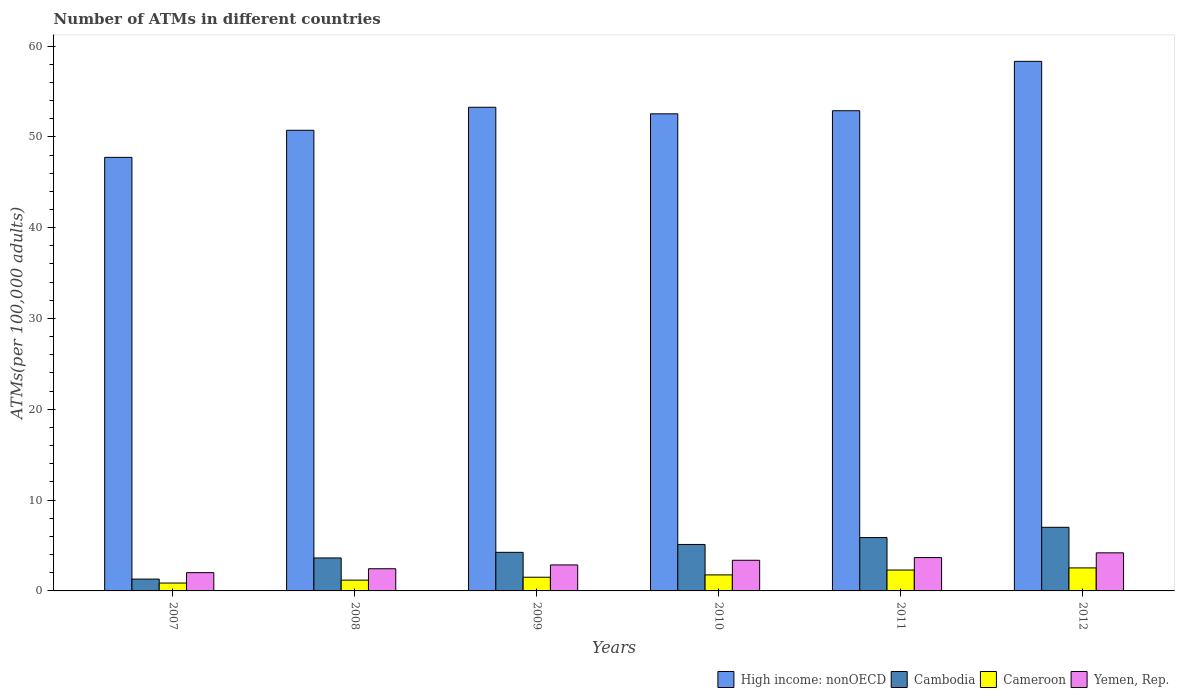Are the number of bars per tick equal to the number of legend labels?
Offer a very short reply. Yes. How many bars are there on the 6th tick from the right?
Offer a terse response. 4. What is the number of ATMs in Cameroon in 2011?
Give a very brief answer. 2.3. Across all years, what is the maximum number of ATMs in Yemen, Rep.?
Your response must be concise. 4.19. Across all years, what is the minimum number of ATMs in Cambodia?
Your response must be concise. 1.3. In which year was the number of ATMs in Yemen, Rep. maximum?
Give a very brief answer. 2012. In which year was the number of ATMs in Cameroon minimum?
Give a very brief answer. 2007. What is the total number of ATMs in Yemen, Rep. in the graph?
Provide a succinct answer. 18.56. What is the difference between the number of ATMs in High income: nonOECD in 2008 and that in 2010?
Provide a short and direct response. -1.81. What is the difference between the number of ATMs in Yemen, Rep. in 2008 and the number of ATMs in Cambodia in 2010?
Your answer should be very brief. -2.67. What is the average number of ATMs in High income: nonOECD per year?
Provide a succinct answer. 52.57. In the year 2011, what is the difference between the number of ATMs in Cambodia and number of ATMs in High income: nonOECD?
Offer a terse response. -47. In how many years, is the number of ATMs in High income: nonOECD greater than 10?
Ensure brevity in your answer.  6. What is the ratio of the number of ATMs in High income: nonOECD in 2010 to that in 2011?
Your answer should be compact. 0.99. Is the number of ATMs in Cameroon in 2009 less than that in 2010?
Give a very brief answer. Yes. Is the difference between the number of ATMs in Cambodia in 2009 and 2010 greater than the difference between the number of ATMs in High income: nonOECD in 2009 and 2010?
Your answer should be compact. No. What is the difference between the highest and the second highest number of ATMs in High income: nonOECD?
Your response must be concise. 5.05. What is the difference between the highest and the lowest number of ATMs in High income: nonOECD?
Make the answer very short. 10.57. What does the 1st bar from the left in 2010 represents?
Make the answer very short. High income: nonOECD. What does the 1st bar from the right in 2011 represents?
Your answer should be very brief. Yemen, Rep. Are all the bars in the graph horizontal?
Make the answer very short. No. How many years are there in the graph?
Make the answer very short. 6. How many legend labels are there?
Ensure brevity in your answer.  4. What is the title of the graph?
Provide a short and direct response. Number of ATMs in different countries. What is the label or title of the Y-axis?
Offer a very short reply. ATMs(per 100,0 adults). What is the ATMs(per 100,000 adults) of High income: nonOECD in 2007?
Offer a very short reply. 47.74. What is the ATMs(per 100,000 adults) of Cambodia in 2007?
Provide a succinct answer. 1.3. What is the ATMs(per 100,000 adults) in Cameroon in 2007?
Ensure brevity in your answer.  0.87. What is the ATMs(per 100,000 adults) of Yemen, Rep. in 2007?
Make the answer very short. 2.01. What is the ATMs(per 100,000 adults) in High income: nonOECD in 2008?
Keep it short and to the point. 50.72. What is the ATMs(per 100,000 adults) of Cambodia in 2008?
Your answer should be very brief. 3.63. What is the ATMs(per 100,000 adults) in Cameroon in 2008?
Your response must be concise. 1.19. What is the ATMs(per 100,000 adults) in Yemen, Rep. in 2008?
Offer a terse response. 2.44. What is the ATMs(per 100,000 adults) of High income: nonOECD in 2009?
Your response must be concise. 53.26. What is the ATMs(per 100,000 adults) of Cambodia in 2009?
Your response must be concise. 4.25. What is the ATMs(per 100,000 adults) of Cameroon in 2009?
Offer a terse response. 1.51. What is the ATMs(per 100,000 adults) of Yemen, Rep. in 2009?
Offer a very short reply. 2.86. What is the ATMs(per 100,000 adults) of High income: nonOECD in 2010?
Provide a succinct answer. 52.53. What is the ATMs(per 100,000 adults) in Cambodia in 2010?
Your answer should be compact. 5.12. What is the ATMs(per 100,000 adults) of Cameroon in 2010?
Ensure brevity in your answer.  1.77. What is the ATMs(per 100,000 adults) of Yemen, Rep. in 2010?
Keep it short and to the point. 3.38. What is the ATMs(per 100,000 adults) of High income: nonOECD in 2011?
Make the answer very short. 52.87. What is the ATMs(per 100,000 adults) in Cambodia in 2011?
Provide a short and direct response. 5.87. What is the ATMs(per 100,000 adults) of Cameroon in 2011?
Give a very brief answer. 2.3. What is the ATMs(per 100,000 adults) of Yemen, Rep. in 2011?
Keep it short and to the point. 3.67. What is the ATMs(per 100,000 adults) of High income: nonOECD in 2012?
Give a very brief answer. 58.31. What is the ATMs(per 100,000 adults) in Cambodia in 2012?
Offer a terse response. 7. What is the ATMs(per 100,000 adults) in Cameroon in 2012?
Keep it short and to the point. 2.53. What is the ATMs(per 100,000 adults) in Yemen, Rep. in 2012?
Give a very brief answer. 4.19. Across all years, what is the maximum ATMs(per 100,000 adults) in High income: nonOECD?
Offer a terse response. 58.31. Across all years, what is the maximum ATMs(per 100,000 adults) of Cambodia?
Give a very brief answer. 7. Across all years, what is the maximum ATMs(per 100,000 adults) of Cameroon?
Your answer should be very brief. 2.53. Across all years, what is the maximum ATMs(per 100,000 adults) of Yemen, Rep.?
Ensure brevity in your answer.  4.19. Across all years, what is the minimum ATMs(per 100,000 adults) in High income: nonOECD?
Your response must be concise. 47.74. Across all years, what is the minimum ATMs(per 100,000 adults) of Cambodia?
Offer a very short reply. 1.3. Across all years, what is the minimum ATMs(per 100,000 adults) in Cameroon?
Offer a very short reply. 0.87. Across all years, what is the minimum ATMs(per 100,000 adults) of Yemen, Rep.?
Your answer should be compact. 2.01. What is the total ATMs(per 100,000 adults) of High income: nonOECD in the graph?
Provide a succinct answer. 315.44. What is the total ATMs(per 100,000 adults) of Cambodia in the graph?
Your answer should be compact. 27.18. What is the total ATMs(per 100,000 adults) in Cameroon in the graph?
Provide a short and direct response. 10.16. What is the total ATMs(per 100,000 adults) of Yemen, Rep. in the graph?
Give a very brief answer. 18.56. What is the difference between the ATMs(per 100,000 adults) in High income: nonOECD in 2007 and that in 2008?
Offer a terse response. -2.98. What is the difference between the ATMs(per 100,000 adults) in Cambodia in 2007 and that in 2008?
Provide a succinct answer. -2.33. What is the difference between the ATMs(per 100,000 adults) of Cameroon in 2007 and that in 2008?
Provide a short and direct response. -0.32. What is the difference between the ATMs(per 100,000 adults) of Yemen, Rep. in 2007 and that in 2008?
Provide a succinct answer. -0.43. What is the difference between the ATMs(per 100,000 adults) of High income: nonOECD in 2007 and that in 2009?
Your response must be concise. -5.52. What is the difference between the ATMs(per 100,000 adults) in Cambodia in 2007 and that in 2009?
Make the answer very short. -2.94. What is the difference between the ATMs(per 100,000 adults) of Cameroon in 2007 and that in 2009?
Your answer should be compact. -0.64. What is the difference between the ATMs(per 100,000 adults) of Yemen, Rep. in 2007 and that in 2009?
Your answer should be compact. -0.85. What is the difference between the ATMs(per 100,000 adults) of High income: nonOECD in 2007 and that in 2010?
Offer a terse response. -4.8. What is the difference between the ATMs(per 100,000 adults) of Cambodia in 2007 and that in 2010?
Keep it short and to the point. -3.81. What is the difference between the ATMs(per 100,000 adults) of Cameroon in 2007 and that in 2010?
Make the answer very short. -0.9. What is the difference between the ATMs(per 100,000 adults) of Yemen, Rep. in 2007 and that in 2010?
Your response must be concise. -1.36. What is the difference between the ATMs(per 100,000 adults) in High income: nonOECD in 2007 and that in 2011?
Your response must be concise. -5.14. What is the difference between the ATMs(per 100,000 adults) of Cambodia in 2007 and that in 2011?
Provide a succinct answer. -4.57. What is the difference between the ATMs(per 100,000 adults) of Cameroon in 2007 and that in 2011?
Offer a terse response. -1.43. What is the difference between the ATMs(per 100,000 adults) in Yemen, Rep. in 2007 and that in 2011?
Keep it short and to the point. -1.66. What is the difference between the ATMs(per 100,000 adults) in High income: nonOECD in 2007 and that in 2012?
Your answer should be very brief. -10.57. What is the difference between the ATMs(per 100,000 adults) in Cambodia in 2007 and that in 2012?
Offer a very short reply. -5.7. What is the difference between the ATMs(per 100,000 adults) of Cameroon in 2007 and that in 2012?
Your answer should be very brief. -1.67. What is the difference between the ATMs(per 100,000 adults) of Yemen, Rep. in 2007 and that in 2012?
Keep it short and to the point. -2.18. What is the difference between the ATMs(per 100,000 adults) in High income: nonOECD in 2008 and that in 2009?
Give a very brief answer. -2.53. What is the difference between the ATMs(per 100,000 adults) of Cambodia in 2008 and that in 2009?
Offer a terse response. -0.62. What is the difference between the ATMs(per 100,000 adults) of Cameroon in 2008 and that in 2009?
Your answer should be very brief. -0.32. What is the difference between the ATMs(per 100,000 adults) of Yemen, Rep. in 2008 and that in 2009?
Give a very brief answer. -0.42. What is the difference between the ATMs(per 100,000 adults) of High income: nonOECD in 2008 and that in 2010?
Ensure brevity in your answer.  -1.81. What is the difference between the ATMs(per 100,000 adults) in Cambodia in 2008 and that in 2010?
Make the answer very short. -1.49. What is the difference between the ATMs(per 100,000 adults) in Cameroon in 2008 and that in 2010?
Ensure brevity in your answer.  -0.58. What is the difference between the ATMs(per 100,000 adults) in Yemen, Rep. in 2008 and that in 2010?
Provide a succinct answer. -0.93. What is the difference between the ATMs(per 100,000 adults) of High income: nonOECD in 2008 and that in 2011?
Your answer should be compact. -2.15. What is the difference between the ATMs(per 100,000 adults) in Cambodia in 2008 and that in 2011?
Your answer should be compact. -2.24. What is the difference between the ATMs(per 100,000 adults) in Cameroon in 2008 and that in 2011?
Ensure brevity in your answer.  -1.11. What is the difference between the ATMs(per 100,000 adults) in Yemen, Rep. in 2008 and that in 2011?
Give a very brief answer. -1.23. What is the difference between the ATMs(per 100,000 adults) of High income: nonOECD in 2008 and that in 2012?
Ensure brevity in your answer.  -7.59. What is the difference between the ATMs(per 100,000 adults) of Cambodia in 2008 and that in 2012?
Give a very brief answer. -3.37. What is the difference between the ATMs(per 100,000 adults) in Cameroon in 2008 and that in 2012?
Provide a succinct answer. -1.35. What is the difference between the ATMs(per 100,000 adults) in Yemen, Rep. in 2008 and that in 2012?
Provide a short and direct response. -1.75. What is the difference between the ATMs(per 100,000 adults) of High income: nonOECD in 2009 and that in 2010?
Offer a terse response. 0.72. What is the difference between the ATMs(per 100,000 adults) in Cambodia in 2009 and that in 2010?
Offer a terse response. -0.87. What is the difference between the ATMs(per 100,000 adults) in Cameroon in 2009 and that in 2010?
Provide a succinct answer. -0.26. What is the difference between the ATMs(per 100,000 adults) in Yemen, Rep. in 2009 and that in 2010?
Make the answer very short. -0.51. What is the difference between the ATMs(per 100,000 adults) in High income: nonOECD in 2009 and that in 2011?
Keep it short and to the point. 0.38. What is the difference between the ATMs(per 100,000 adults) of Cambodia in 2009 and that in 2011?
Your answer should be very brief. -1.62. What is the difference between the ATMs(per 100,000 adults) of Cameroon in 2009 and that in 2011?
Give a very brief answer. -0.79. What is the difference between the ATMs(per 100,000 adults) in Yemen, Rep. in 2009 and that in 2011?
Give a very brief answer. -0.81. What is the difference between the ATMs(per 100,000 adults) in High income: nonOECD in 2009 and that in 2012?
Your answer should be compact. -5.05. What is the difference between the ATMs(per 100,000 adults) in Cambodia in 2009 and that in 2012?
Your answer should be compact. -2.76. What is the difference between the ATMs(per 100,000 adults) in Cameroon in 2009 and that in 2012?
Keep it short and to the point. -1.03. What is the difference between the ATMs(per 100,000 adults) in Yemen, Rep. in 2009 and that in 2012?
Provide a succinct answer. -1.33. What is the difference between the ATMs(per 100,000 adults) of High income: nonOECD in 2010 and that in 2011?
Give a very brief answer. -0.34. What is the difference between the ATMs(per 100,000 adults) of Cambodia in 2010 and that in 2011?
Keep it short and to the point. -0.76. What is the difference between the ATMs(per 100,000 adults) in Cameroon in 2010 and that in 2011?
Offer a very short reply. -0.53. What is the difference between the ATMs(per 100,000 adults) in Yemen, Rep. in 2010 and that in 2011?
Keep it short and to the point. -0.29. What is the difference between the ATMs(per 100,000 adults) of High income: nonOECD in 2010 and that in 2012?
Ensure brevity in your answer.  -5.78. What is the difference between the ATMs(per 100,000 adults) of Cambodia in 2010 and that in 2012?
Provide a short and direct response. -1.89. What is the difference between the ATMs(per 100,000 adults) in Cameroon in 2010 and that in 2012?
Provide a short and direct response. -0.77. What is the difference between the ATMs(per 100,000 adults) of Yemen, Rep. in 2010 and that in 2012?
Your answer should be very brief. -0.82. What is the difference between the ATMs(per 100,000 adults) of High income: nonOECD in 2011 and that in 2012?
Offer a very short reply. -5.44. What is the difference between the ATMs(per 100,000 adults) in Cambodia in 2011 and that in 2012?
Keep it short and to the point. -1.13. What is the difference between the ATMs(per 100,000 adults) of Cameroon in 2011 and that in 2012?
Your answer should be very brief. -0.24. What is the difference between the ATMs(per 100,000 adults) in Yemen, Rep. in 2011 and that in 2012?
Provide a short and direct response. -0.52. What is the difference between the ATMs(per 100,000 adults) of High income: nonOECD in 2007 and the ATMs(per 100,000 adults) of Cambodia in 2008?
Offer a terse response. 44.11. What is the difference between the ATMs(per 100,000 adults) of High income: nonOECD in 2007 and the ATMs(per 100,000 adults) of Cameroon in 2008?
Provide a short and direct response. 46.55. What is the difference between the ATMs(per 100,000 adults) in High income: nonOECD in 2007 and the ATMs(per 100,000 adults) in Yemen, Rep. in 2008?
Offer a terse response. 45.3. What is the difference between the ATMs(per 100,000 adults) in Cambodia in 2007 and the ATMs(per 100,000 adults) in Cameroon in 2008?
Give a very brief answer. 0.11. What is the difference between the ATMs(per 100,000 adults) in Cambodia in 2007 and the ATMs(per 100,000 adults) in Yemen, Rep. in 2008?
Give a very brief answer. -1.14. What is the difference between the ATMs(per 100,000 adults) of Cameroon in 2007 and the ATMs(per 100,000 adults) of Yemen, Rep. in 2008?
Offer a very short reply. -1.57. What is the difference between the ATMs(per 100,000 adults) in High income: nonOECD in 2007 and the ATMs(per 100,000 adults) in Cambodia in 2009?
Give a very brief answer. 43.49. What is the difference between the ATMs(per 100,000 adults) in High income: nonOECD in 2007 and the ATMs(per 100,000 adults) in Cameroon in 2009?
Your answer should be very brief. 46.23. What is the difference between the ATMs(per 100,000 adults) in High income: nonOECD in 2007 and the ATMs(per 100,000 adults) in Yemen, Rep. in 2009?
Keep it short and to the point. 44.88. What is the difference between the ATMs(per 100,000 adults) in Cambodia in 2007 and the ATMs(per 100,000 adults) in Cameroon in 2009?
Provide a succinct answer. -0.2. What is the difference between the ATMs(per 100,000 adults) of Cambodia in 2007 and the ATMs(per 100,000 adults) of Yemen, Rep. in 2009?
Provide a short and direct response. -1.56. What is the difference between the ATMs(per 100,000 adults) of Cameroon in 2007 and the ATMs(per 100,000 adults) of Yemen, Rep. in 2009?
Offer a terse response. -1.99. What is the difference between the ATMs(per 100,000 adults) of High income: nonOECD in 2007 and the ATMs(per 100,000 adults) of Cambodia in 2010?
Provide a short and direct response. 42.62. What is the difference between the ATMs(per 100,000 adults) in High income: nonOECD in 2007 and the ATMs(per 100,000 adults) in Cameroon in 2010?
Your answer should be compact. 45.97. What is the difference between the ATMs(per 100,000 adults) of High income: nonOECD in 2007 and the ATMs(per 100,000 adults) of Yemen, Rep. in 2010?
Offer a terse response. 44.36. What is the difference between the ATMs(per 100,000 adults) in Cambodia in 2007 and the ATMs(per 100,000 adults) in Cameroon in 2010?
Provide a succinct answer. -0.46. What is the difference between the ATMs(per 100,000 adults) of Cambodia in 2007 and the ATMs(per 100,000 adults) of Yemen, Rep. in 2010?
Your answer should be very brief. -2.07. What is the difference between the ATMs(per 100,000 adults) in Cameroon in 2007 and the ATMs(per 100,000 adults) in Yemen, Rep. in 2010?
Offer a terse response. -2.51. What is the difference between the ATMs(per 100,000 adults) of High income: nonOECD in 2007 and the ATMs(per 100,000 adults) of Cambodia in 2011?
Offer a terse response. 41.87. What is the difference between the ATMs(per 100,000 adults) in High income: nonOECD in 2007 and the ATMs(per 100,000 adults) in Cameroon in 2011?
Give a very brief answer. 45.44. What is the difference between the ATMs(per 100,000 adults) of High income: nonOECD in 2007 and the ATMs(per 100,000 adults) of Yemen, Rep. in 2011?
Your answer should be compact. 44.07. What is the difference between the ATMs(per 100,000 adults) in Cambodia in 2007 and the ATMs(per 100,000 adults) in Cameroon in 2011?
Provide a short and direct response. -1. What is the difference between the ATMs(per 100,000 adults) in Cambodia in 2007 and the ATMs(per 100,000 adults) in Yemen, Rep. in 2011?
Give a very brief answer. -2.37. What is the difference between the ATMs(per 100,000 adults) in Cameroon in 2007 and the ATMs(per 100,000 adults) in Yemen, Rep. in 2011?
Your response must be concise. -2.8. What is the difference between the ATMs(per 100,000 adults) in High income: nonOECD in 2007 and the ATMs(per 100,000 adults) in Cambodia in 2012?
Your response must be concise. 40.73. What is the difference between the ATMs(per 100,000 adults) of High income: nonOECD in 2007 and the ATMs(per 100,000 adults) of Cameroon in 2012?
Provide a short and direct response. 45.2. What is the difference between the ATMs(per 100,000 adults) in High income: nonOECD in 2007 and the ATMs(per 100,000 adults) in Yemen, Rep. in 2012?
Ensure brevity in your answer.  43.55. What is the difference between the ATMs(per 100,000 adults) of Cambodia in 2007 and the ATMs(per 100,000 adults) of Cameroon in 2012?
Ensure brevity in your answer.  -1.23. What is the difference between the ATMs(per 100,000 adults) in Cambodia in 2007 and the ATMs(per 100,000 adults) in Yemen, Rep. in 2012?
Ensure brevity in your answer.  -2.89. What is the difference between the ATMs(per 100,000 adults) of Cameroon in 2007 and the ATMs(per 100,000 adults) of Yemen, Rep. in 2012?
Offer a very short reply. -3.32. What is the difference between the ATMs(per 100,000 adults) in High income: nonOECD in 2008 and the ATMs(per 100,000 adults) in Cambodia in 2009?
Give a very brief answer. 46.47. What is the difference between the ATMs(per 100,000 adults) of High income: nonOECD in 2008 and the ATMs(per 100,000 adults) of Cameroon in 2009?
Give a very brief answer. 49.21. What is the difference between the ATMs(per 100,000 adults) in High income: nonOECD in 2008 and the ATMs(per 100,000 adults) in Yemen, Rep. in 2009?
Make the answer very short. 47.86. What is the difference between the ATMs(per 100,000 adults) in Cambodia in 2008 and the ATMs(per 100,000 adults) in Cameroon in 2009?
Provide a succinct answer. 2.12. What is the difference between the ATMs(per 100,000 adults) of Cambodia in 2008 and the ATMs(per 100,000 adults) of Yemen, Rep. in 2009?
Your response must be concise. 0.77. What is the difference between the ATMs(per 100,000 adults) of Cameroon in 2008 and the ATMs(per 100,000 adults) of Yemen, Rep. in 2009?
Keep it short and to the point. -1.67. What is the difference between the ATMs(per 100,000 adults) of High income: nonOECD in 2008 and the ATMs(per 100,000 adults) of Cambodia in 2010?
Your answer should be very brief. 45.61. What is the difference between the ATMs(per 100,000 adults) in High income: nonOECD in 2008 and the ATMs(per 100,000 adults) in Cameroon in 2010?
Keep it short and to the point. 48.96. What is the difference between the ATMs(per 100,000 adults) in High income: nonOECD in 2008 and the ATMs(per 100,000 adults) in Yemen, Rep. in 2010?
Ensure brevity in your answer.  47.35. What is the difference between the ATMs(per 100,000 adults) of Cambodia in 2008 and the ATMs(per 100,000 adults) of Cameroon in 2010?
Give a very brief answer. 1.87. What is the difference between the ATMs(per 100,000 adults) in Cambodia in 2008 and the ATMs(per 100,000 adults) in Yemen, Rep. in 2010?
Provide a succinct answer. 0.25. What is the difference between the ATMs(per 100,000 adults) in Cameroon in 2008 and the ATMs(per 100,000 adults) in Yemen, Rep. in 2010?
Ensure brevity in your answer.  -2.19. What is the difference between the ATMs(per 100,000 adults) of High income: nonOECD in 2008 and the ATMs(per 100,000 adults) of Cambodia in 2011?
Keep it short and to the point. 44.85. What is the difference between the ATMs(per 100,000 adults) in High income: nonOECD in 2008 and the ATMs(per 100,000 adults) in Cameroon in 2011?
Your answer should be compact. 48.42. What is the difference between the ATMs(per 100,000 adults) of High income: nonOECD in 2008 and the ATMs(per 100,000 adults) of Yemen, Rep. in 2011?
Your answer should be very brief. 47.05. What is the difference between the ATMs(per 100,000 adults) in Cambodia in 2008 and the ATMs(per 100,000 adults) in Cameroon in 2011?
Ensure brevity in your answer.  1.33. What is the difference between the ATMs(per 100,000 adults) in Cambodia in 2008 and the ATMs(per 100,000 adults) in Yemen, Rep. in 2011?
Ensure brevity in your answer.  -0.04. What is the difference between the ATMs(per 100,000 adults) in Cameroon in 2008 and the ATMs(per 100,000 adults) in Yemen, Rep. in 2011?
Your answer should be compact. -2.48. What is the difference between the ATMs(per 100,000 adults) of High income: nonOECD in 2008 and the ATMs(per 100,000 adults) of Cambodia in 2012?
Make the answer very short. 43.72. What is the difference between the ATMs(per 100,000 adults) in High income: nonOECD in 2008 and the ATMs(per 100,000 adults) in Cameroon in 2012?
Give a very brief answer. 48.19. What is the difference between the ATMs(per 100,000 adults) of High income: nonOECD in 2008 and the ATMs(per 100,000 adults) of Yemen, Rep. in 2012?
Keep it short and to the point. 46.53. What is the difference between the ATMs(per 100,000 adults) in Cambodia in 2008 and the ATMs(per 100,000 adults) in Cameroon in 2012?
Provide a short and direct response. 1.1. What is the difference between the ATMs(per 100,000 adults) in Cambodia in 2008 and the ATMs(per 100,000 adults) in Yemen, Rep. in 2012?
Offer a very short reply. -0.56. What is the difference between the ATMs(per 100,000 adults) of Cameroon in 2008 and the ATMs(per 100,000 adults) of Yemen, Rep. in 2012?
Ensure brevity in your answer.  -3. What is the difference between the ATMs(per 100,000 adults) in High income: nonOECD in 2009 and the ATMs(per 100,000 adults) in Cambodia in 2010?
Make the answer very short. 48.14. What is the difference between the ATMs(per 100,000 adults) in High income: nonOECD in 2009 and the ATMs(per 100,000 adults) in Cameroon in 2010?
Provide a succinct answer. 51.49. What is the difference between the ATMs(per 100,000 adults) in High income: nonOECD in 2009 and the ATMs(per 100,000 adults) in Yemen, Rep. in 2010?
Keep it short and to the point. 49.88. What is the difference between the ATMs(per 100,000 adults) in Cambodia in 2009 and the ATMs(per 100,000 adults) in Cameroon in 2010?
Keep it short and to the point. 2.48. What is the difference between the ATMs(per 100,000 adults) of Cambodia in 2009 and the ATMs(per 100,000 adults) of Yemen, Rep. in 2010?
Your answer should be very brief. 0.87. What is the difference between the ATMs(per 100,000 adults) of Cameroon in 2009 and the ATMs(per 100,000 adults) of Yemen, Rep. in 2010?
Make the answer very short. -1.87. What is the difference between the ATMs(per 100,000 adults) in High income: nonOECD in 2009 and the ATMs(per 100,000 adults) in Cambodia in 2011?
Provide a succinct answer. 47.38. What is the difference between the ATMs(per 100,000 adults) of High income: nonOECD in 2009 and the ATMs(per 100,000 adults) of Cameroon in 2011?
Your answer should be compact. 50.96. What is the difference between the ATMs(per 100,000 adults) of High income: nonOECD in 2009 and the ATMs(per 100,000 adults) of Yemen, Rep. in 2011?
Offer a terse response. 49.59. What is the difference between the ATMs(per 100,000 adults) of Cambodia in 2009 and the ATMs(per 100,000 adults) of Cameroon in 2011?
Offer a very short reply. 1.95. What is the difference between the ATMs(per 100,000 adults) of Cambodia in 2009 and the ATMs(per 100,000 adults) of Yemen, Rep. in 2011?
Your answer should be very brief. 0.58. What is the difference between the ATMs(per 100,000 adults) of Cameroon in 2009 and the ATMs(per 100,000 adults) of Yemen, Rep. in 2011?
Ensure brevity in your answer.  -2.16. What is the difference between the ATMs(per 100,000 adults) of High income: nonOECD in 2009 and the ATMs(per 100,000 adults) of Cambodia in 2012?
Provide a succinct answer. 46.25. What is the difference between the ATMs(per 100,000 adults) of High income: nonOECD in 2009 and the ATMs(per 100,000 adults) of Cameroon in 2012?
Keep it short and to the point. 50.72. What is the difference between the ATMs(per 100,000 adults) in High income: nonOECD in 2009 and the ATMs(per 100,000 adults) in Yemen, Rep. in 2012?
Offer a terse response. 49.06. What is the difference between the ATMs(per 100,000 adults) in Cambodia in 2009 and the ATMs(per 100,000 adults) in Cameroon in 2012?
Your response must be concise. 1.71. What is the difference between the ATMs(per 100,000 adults) in Cambodia in 2009 and the ATMs(per 100,000 adults) in Yemen, Rep. in 2012?
Offer a very short reply. 0.05. What is the difference between the ATMs(per 100,000 adults) of Cameroon in 2009 and the ATMs(per 100,000 adults) of Yemen, Rep. in 2012?
Keep it short and to the point. -2.69. What is the difference between the ATMs(per 100,000 adults) of High income: nonOECD in 2010 and the ATMs(per 100,000 adults) of Cambodia in 2011?
Your answer should be very brief. 46.66. What is the difference between the ATMs(per 100,000 adults) of High income: nonOECD in 2010 and the ATMs(per 100,000 adults) of Cameroon in 2011?
Offer a very short reply. 50.24. What is the difference between the ATMs(per 100,000 adults) of High income: nonOECD in 2010 and the ATMs(per 100,000 adults) of Yemen, Rep. in 2011?
Give a very brief answer. 48.86. What is the difference between the ATMs(per 100,000 adults) in Cambodia in 2010 and the ATMs(per 100,000 adults) in Cameroon in 2011?
Your answer should be compact. 2.82. What is the difference between the ATMs(per 100,000 adults) of Cambodia in 2010 and the ATMs(per 100,000 adults) of Yemen, Rep. in 2011?
Your response must be concise. 1.45. What is the difference between the ATMs(per 100,000 adults) of Cameroon in 2010 and the ATMs(per 100,000 adults) of Yemen, Rep. in 2011?
Provide a short and direct response. -1.91. What is the difference between the ATMs(per 100,000 adults) in High income: nonOECD in 2010 and the ATMs(per 100,000 adults) in Cambodia in 2012?
Provide a short and direct response. 45.53. What is the difference between the ATMs(per 100,000 adults) in High income: nonOECD in 2010 and the ATMs(per 100,000 adults) in Cameroon in 2012?
Your answer should be compact. 50. What is the difference between the ATMs(per 100,000 adults) of High income: nonOECD in 2010 and the ATMs(per 100,000 adults) of Yemen, Rep. in 2012?
Your answer should be compact. 48.34. What is the difference between the ATMs(per 100,000 adults) in Cambodia in 2010 and the ATMs(per 100,000 adults) in Cameroon in 2012?
Your response must be concise. 2.58. What is the difference between the ATMs(per 100,000 adults) in Cambodia in 2010 and the ATMs(per 100,000 adults) in Yemen, Rep. in 2012?
Your response must be concise. 0.92. What is the difference between the ATMs(per 100,000 adults) of Cameroon in 2010 and the ATMs(per 100,000 adults) of Yemen, Rep. in 2012?
Your answer should be compact. -2.43. What is the difference between the ATMs(per 100,000 adults) in High income: nonOECD in 2011 and the ATMs(per 100,000 adults) in Cambodia in 2012?
Ensure brevity in your answer.  45.87. What is the difference between the ATMs(per 100,000 adults) of High income: nonOECD in 2011 and the ATMs(per 100,000 adults) of Cameroon in 2012?
Give a very brief answer. 50.34. What is the difference between the ATMs(per 100,000 adults) of High income: nonOECD in 2011 and the ATMs(per 100,000 adults) of Yemen, Rep. in 2012?
Give a very brief answer. 48.68. What is the difference between the ATMs(per 100,000 adults) of Cambodia in 2011 and the ATMs(per 100,000 adults) of Cameroon in 2012?
Make the answer very short. 3.34. What is the difference between the ATMs(per 100,000 adults) of Cambodia in 2011 and the ATMs(per 100,000 adults) of Yemen, Rep. in 2012?
Make the answer very short. 1.68. What is the difference between the ATMs(per 100,000 adults) in Cameroon in 2011 and the ATMs(per 100,000 adults) in Yemen, Rep. in 2012?
Keep it short and to the point. -1.9. What is the average ATMs(per 100,000 adults) in High income: nonOECD per year?
Give a very brief answer. 52.57. What is the average ATMs(per 100,000 adults) of Cambodia per year?
Make the answer very short. 4.53. What is the average ATMs(per 100,000 adults) of Cameroon per year?
Your response must be concise. 1.69. What is the average ATMs(per 100,000 adults) of Yemen, Rep. per year?
Ensure brevity in your answer.  3.09. In the year 2007, what is the difference between the ATMs(per 100,000 adults) in High income: nonOECD and ATMs(per 100,000 adults) in Cambodia?
Offer a very short reply. 46.44. In the year 2007, what is the difference between the ATMs(per 100,000 adults) in High income: nonOECD and ATMs(per 100,000 adults) in Cameroon?
Give a very brief answer. 46.87. In the year 2007, what is the difference between the ATMs(per 100,000 adults) of High income: nonOECD and ATMs(per 100,000 adults) of Yemen, Rep.?
Ensure brevity in your answer.  45.73. In the year 2007, what is the difference between the ATMs(per 100,000 adults) of Cambodia and ATMs(per 100,000 adults) of Cameroon?
Offer a very short reply. 0.43. In the year 2007, what is the difference between the ATMs(per 100,000 adults) in Cambodia and ATMs(per 100,000 adults) in Yemen, Rep.?
Ensure brevity in your answer.  -0.71. In the year 2007, what is the difference between the ATMs(per 100,000 adults) of Cameroon and ATMs(per 100,000 adults) of Yemen, Rep.?
Provide a short and direct response. -1.14. In the year 2008, what is the difference between the ATMs(per 100,000 adults) in High income: nonOECD and ATMs(per 100,000 adults) in Cambodia?
Offer a very short reply. 47.09. In the year 2008, what is the difference between the ATMs(per 100,000 adults) of High income: nonOECD and ATMs(per 100,000 adults) of Cameroon?
Offer a terse response. 49.53. In the year 2008, what is the difference between the ATMs(per 100,000 adults) in High income: nonOECD and ATMs(per 100,000 adults) in Yemen, Rep.?
Offer a very short reply. 48.28. In the year 2008, what is the difference between the ATMs(per 100,000 adults) in Cambodia and ATMs(per 100,000 adults) in Cameroon?
Make the answer very short. 2.44. In the year 2008, what is the difference between the ATMs(per 100,000 adults) in Cambodia and ATMs(per 100,000 adults) in Yemen, Rep.?
Your answer should be very brief. 1.19. In the year 2008, what is the difference between the ATMs(per 100,000 adults) in Cameroon and ATMs(per 100,000 adults) in Yemen, Rep.?
Give a very brief answer. -1.25. In the year 2009, what is the difference between the ATMs(per 100,000 adults) of High income: nonOECD and ATMs(per 100,000 adults) of Cambodia?
Your answer should be very brief. 49.01. In the year 2009, what is the difference between the ATMs(per 100,000 adults) in High income: nonOECD and ATMs(per 100,000 adults) in Cameroon?
Provide a succinct answer. 51.75. In the year 2009, what is the difference between the ATMs(per 100,000 adults) in High income: nonOECD and ATMs(per 100,000 adults) in Yemen, Rep.?
Provide a succinct answer. 50.39. In the year 2009, what is the difference between the ATMs(per 100,000 adults) of Cambodia and ATMs(per 100,000 adults) of Cameroon?
Give a very brief answer. 2.74. In the year 2009, what is the difference between the ATMs(per 100,000 adults) in Cambodia and ATMs(per 100,000 adults) in Yemen, Rep.?
Give a very brief answer. 1.38. In the year 2009, what is the difference between the ATMs(per 100,000 adults) of Cameroon and ATMs(per 100,000 adults) of Yemen, Rep.?
Provide a short and direct response. -1.36. In the year 2010, what is the difference between the ATMs(per 100,000 adults) of High income: nonOECD and ATMs(per 100,000 adults) of Cambodia?
Your answer should be compact. 47.42. In the year 2010, what is the difference between the ATMs(per 100,000 adults) of High income: nonOECD and ATMs(per 100,000 adults) of Cameroon?
Give a very brief answer. 50.77. In the year 2010, what is the difference between the ATMs(per 100,000 adults) of High income: nonOECD and ATMs(per 100,000 adults) of Yemen, Rep.?
Make the answer very short. 49.16. In the year 2010, what is the difference between the ATMs(per 100,000 adults) of Cambodia and ATMs(per 100,000 adults) of Cameroon?
Provide a succinct answer. 3.35. In the year 2010, what is the difference between the ATMs(per 100,000 adults) of Cambodia and ATMs(per 100,000 adults) of Yemen, Rep.?
Provide a succinct answer. 1.74. In the year 2010, what is the difference between the ATMs(per 100,000 adults) in Cameroon and ATMs(per 100,000 adults) in Yemen, Rep.?
Offer a very short reply. -1.61. In the year 2011, what is the difference between the ATMs(per 100,000 adults) in High income: nonOECD and ATMs(per 100,000 adults) in Cambodia?
Make the answer very short. 47. In the year 2011, what is the difference between the ATMs(per 100,000 adults) in High income: nonOECD and ATMs(per 100,000 adults) in Cameroon?
Give a very brief answer. 50.58. In the year 2011, what is the difference between the ATMs(per 100,000 adults) in High income: nonOECD and ATMs(per 100,000 adults) in Yemen, Rep.?
Offer a terse response. 49.2. In the year 2011, what is the difference between the ATMs(per 100,000 adults) of Cambodia and ATMs(per 100,000 adults) of Cameroon?
Your answer should be compact. 3.57. In the year 2011, what is the difference between the ATMs(per 100,000 adults) in Cambodia and ATMs(per 100,000 adults) in Yemen, Rep.?
Ensure brevity in your answer.  2.2. In the year 2011, what is the difference between the ATMs(per 100,000 adults) in Cameroon and ATMs(per 100,000 adults) in Yemen, Rep.?
Provide a short and direct response. -1.37. In the year 2012, what is the difference between the ATMs(per 100,000 adults) of High income: nonOECD and ATMs(per 100,000 adults) of Cambodia?
Your answer should be compact. 51.31. In the year 2012, what is the difference between the ATMs(per 100,000 adults) of High income: nonOECD and ATMs(per 100,000 adults) of Cameroon?
Make the answer very short. 55.78. In the year 2012, what is the difference between the ATMs(per 100,000 adults) in High income: nonOECD and ATMs(per 100,000 adults) in Yemen, Rep.?
Your answer should be very brief. 54.12. In the year 2012, what is the difference between the ATMs(per 100,000 adults) of Cambodia and ATMs(per 100,000 adults) of Cameroon?
Your answer should be very brief. 4.47. In the year 2012, what is the difference between the ATMs(per 100,000 adults) in Cambodia and ATMs(per 100,000 adults) in Yemen, Rep.?
Give a very brief answer. 2.81. In the year 2012, what is the difference between the ATMs(per 100,000 adults) in Cameroon and ATMs(per 100,000 adults) in Yemen, Rep.?
Your answer should be very brief. -1.66. What is the ratio of the ATMs(per 100,000 adults) in High income: nonOECD in 2007 to that in 2008?
Provide a short and direct response. 0.94. What is the ratio of the ATMs(per 100,000 adults) in Cambodia in 2007 to that in 2008?
Keep it short and to the point. 0.36. What is the ratio of the ATMs(per 100,000 adults) of Cameroon in 2007 to that in 2008?
Your answer should be very brief. 0.73. What is the ratio of the ATMs(per 100,000 adults) in Yemen, Rep. in 2007 to that in 2008?
Your answer should be compact. 0.82. What is the ratio of the ATMs(per 100,000 adults) in High income: nonOECD in 2007 to that in 2009?
Provide a succinct answer. 0.9. What is the ratio of the ATMs(per 100,000 adults) of Cambodia in 2007 to that in 2009?
Keep it short and to the point. 0.31. What is the ratio of the ATMs(per 100,000 adults) in Cameroon in 2007 to that in 2009?
Offer a very short reply. 0.58. What is the ratio of the ATMs(per 100,000 adults) in Yemen, Rep. in 2007 to that in 2009?
Offer a very short reply. 0.7. What is the ratio of the ATMs(per 100,000 adults) of High income: nonOECD in 2007 to that in 2010?
Make the answer very short. 0.91. What is the ratio of the ATMs(per 100,000 adults) in Cambodia in 2007 to that in 2010?
Make the answer very short. 0.25. What is the ratio of the ATMs(per 100,000 adults) of Cameroon in 2007 to that in 2010?
Provide a short and direct response. 0.49. What is the ratio of the ATMs(per 100,000 adults) of Yemen, Rep. in 2007 to that in 2010?
Your answer should be very brief. 0.6. What is the ratio of the ATMs(per 100,000 adults) in High income: nonOECD in 2007 to that in 2011?
Provide a succinct answer. 0.9. What is the ratio of the ATMs(per 100,000 adults) in Cambodia in 2007 to that in 2011?
Make the answer very short. 0.22. What is the ratio of the ATMs(per 100,000 adults) in Cameroon in 2007 to that in 2011?
Provide a short and direct response. 0.38. What is the ratio of the ATMs(per 100,000 adults) in Yemen, Rep. in 2007 to that in 2011?
Make the answer very short. 0.55. What is the ratio of the ATMs(per 100,000 adults) in High income: nonOECD in 2007 to that in 2012?
Your answer should be compact. 0.82. What is the ratio of the ATMs(per 100,000 adults) of Cambodia in 2007 to that in 2012?
Provide a short and direct response. 0.19. What is the ratio of the ATMs(per 100,000 adults) of Cameroon in 2007 to that in 2012?
Your answer should be compact. 0.34. What is the ratio of the ATMs(per 100,000 adults) of Yemen, Rep. in 2007 to that in 2012?
Give a very brief answer. 0.48. What is the ratio of the ATMs(per 100,000 adults) of Cambodia in 2008 to that in 2009?
Give a very brief answer. 0.85. What is the ratio of the ATMs(per 100,000 adults) in Cameroon in 2008 to that in 2009?
Make the answer very short. 0.79. What is the ratio of the ATMs(per 100,000 adults) of Yemen, Rep. in 2008 to that in 2009?
Your response must be concise. 0.85. What is the ratio of the ATMs(per 100,000 adults) in High income: nonOECD in 2008 to that in 2010?
Provide a short and direct response. 0.97. What is the ratio of the ATMs(per 100,000 adults) of Cambodia in 2008 to that in 2010?
Provide a short and direct response. 0.71. What is the ratio of the ATMs(per 100,000 adults) of Cameroon in 2008 to that in 2010?
Give a very brief answer. 0.67. What is the ratio of the ATMs(per 100,000 adults) in Yemen, Rep. in 2008 to that in 2010?
Make the answer very short. 0.72. What is the ratio of the ATMs(per 100,000 adults) of High income: nonOECD in 2008 to that in 2011?
Keep it short and to the point. 0.96. What is the ratio of the ATMs(per 100,000 adults) of Cambodia in 2008 to that in 2011?
Provide a short and direct response. 0.62. What is the ratio of the ATMs(per 100,000 adults) in Cameroon in 2008 to that in 2011?
Your answer should be very brief. 0.52. What is the ratio of the ATMs(per 100,000 adults) in Yemen, Rep. in 2008 to that in 2011?
Offer a very short reply. 0.67. What is the ratio of the ATMs(per 100,000 adults) of High income: nonOECD in 2008 to that in 2012?
Offer a terse response. 0.87. What is the ratio of the ATMs(per 100,000 adults) in Cambodia in 2008 to that in 2012?
Offer a very short reply. 0.52. What is the ratio of the ATMs(per 100,000 adults) of Cameroon in 2008 to that in 2012?
Offer a terse response. 0.47. What is the ratio of the ATMs(per 100,000 adults) in Yemen, Rep. in 2008 to that in 2012?
Make the answer very short. 0.58. What is the ratio of the ATMs(per 100,000 adults) of High income: nonOECD in 2009 to that in 2010?
Your answer should be compact. 1.01. What is the ratio of the ATMs(per 100,000 adults) in Cambodia in 2009 to that in 2010?
Offer a terse response. 0.83. What is the ratio of the ATMs(per 100,000 adults) in Cameroon in 2009 to that in 2010?
Give a very brief answer. 0.85. What is the ratio of the ATMs(per 100,000 adults) in Yemen, Rep. in 2009 to that in 2010?
Provide a short and direct response. 0.85. What is the ratio of the ATMs(per 100,000 adults) in Cambodia in 2009 to that in 2011?
Offer a terse response. 0.72. What is the ratio of the ATMs(per 100,000 adults) of Cameroon in 2009 to that in 2011?
Your answer should be very brief. 0.66. What is the ratio of the ATMs(per 100,000 adults) in Yemen, Rep. in 2009 to that in 2011?
Offer a terse response. 0.78. What is the ratio of the ATMs(per 100,000 adults) of High income: nonOECD in 2009 to that in 2012?
Make the answer very short. 0.91. What is the ratio of the ATMs(per 100,000 adults) of Cambodia in 2009 to that in 2012?
Your response must be concise. 0.61. What is the ratio of the ATMs(per 100,000 adults) in Cameroon in 2009 to that in 2012?
Make the answer very short. 0.59. What is the ratio of the ATMs(per 100,000 adults) of Yemen, Rep. in 2009 to that in 2012?
Offer a terse response. 0.68. What is the ratio of the ATMs(per 100,000 adults) of Cambodia in 2010 to that in 2011?
Provide a short and direct response. 0.87. What is the ratio of the ATMs(per 100,000 adults) of Cameroon in 2010 to that in 2011?
Offer a terse response. 0.77. What is the ratio of the ATMs(per 100,000 adults) in Yemen, Rep. in 2010 to that in 2011?
Your answer should be very brief. 0.92. What is the ratio of the ATMs(per 100,000 adults) in High income: nonOECD in 2010 to that in 2012?
Give a very brief answer. 0.9. What is the ratio of the ATMs(per 100,000 adults) in Cambodia in 2010 to that in 2012?
Provide a short and direct response. 0.73. What is the ratio of the ATMs(per 100,000 adults) in Cameroon in 2010 to that in 2012?
Provide a succinct answer. 0.7. What is the ratio of the ATMs(per 100,000 adults) of Yemen, Rep. in 2010 to that in 2012?
Provide a succinct answer. 0.8. What is the ratio of the ATMs(per 100,000 adults) in High income: nonOECD in 2011 to that in 2012?
Provide a succinct answer. 0.91. What is the ratio of the ATMs(per 100,000 adults) in Cambodia in 2011 to that in 2012?
Make the answer very short. 0.84. What is the ratio of the ATMs(per 100,000 adults) in Cameroon in 2011 to that in 2012?
Keep it short and to the point. 0.91. What is the ratio of the ATMs(per 100,000 adults) in Yemen, Rep. in 2011 to that in 2012?
Provide a short and direct response. 0.88. What is the difference between the highest and the second highest ATMs(per 100,000 adults) of High income: nonOECD?
Your response must be concise. 5.05. What is the difference between the highest and the second highest ATMs(per 100,000 adults) of Cambodia?
Ensure brevity in your answer.  1.13. What is the difference between the highest and the second highest ATMs(per 100,000 adults) of Cameroon?
Provide a short and direct response. 0.24. What is the difference between the highest and the second highest ATMs(per 100,000 adults) of Yemen, Rep.?
Keep it short and to the point. 0.52. What is the difference between the highest and the lowest ATMs(per 100,000 adults) in High income: nonOECD?
Offer a very short reply. 10.57. What is the difference between the highest and the lowest ATMs(per 100,000 adults) in Cambodia?
Keep it short and to the point. 5.7. What is the difference between the highest and the lowest ATMs(per 100,000 adults) in Cameroon?
Your answer should be compact. 1.67. What is the difference between the highest and the lowest ATMs(per 100,000 adults) of Yemen, Rep.?
Your answer should be very brief. 2.18. 